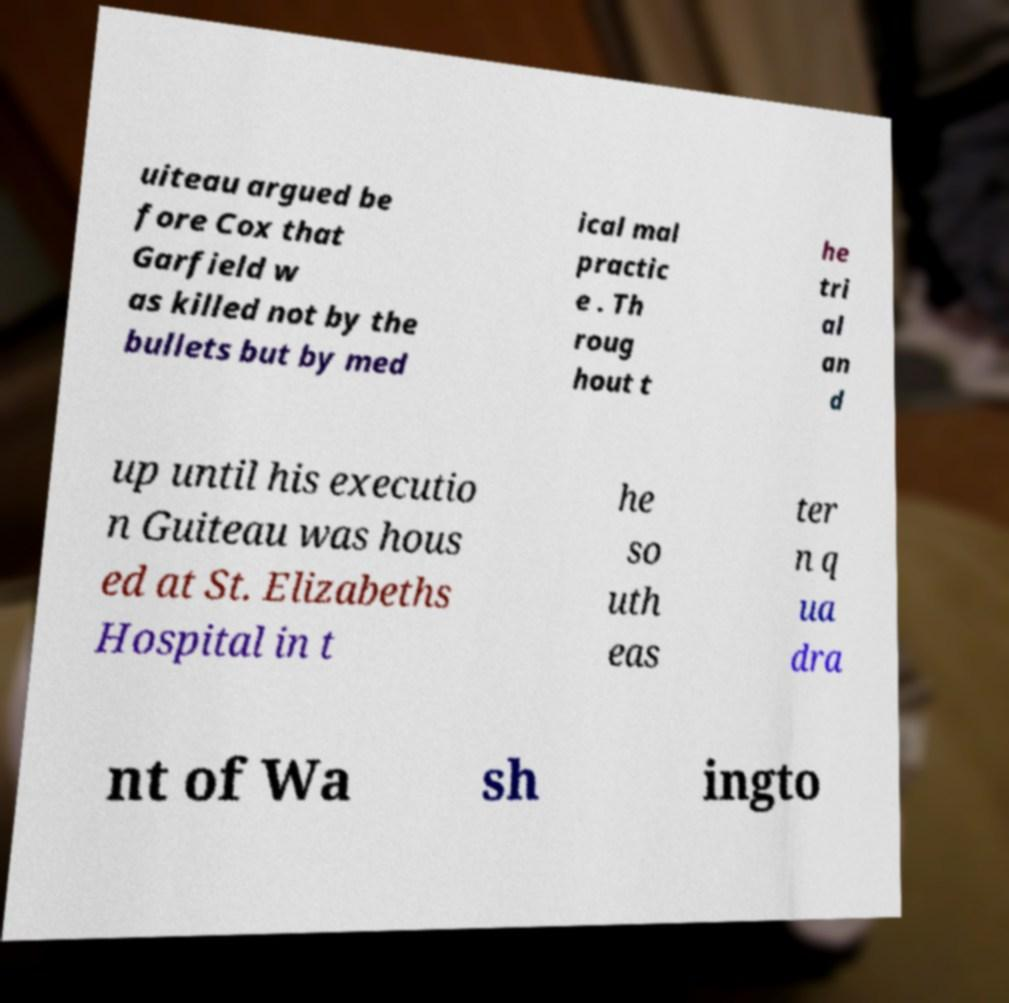Please identify and transcribe the text found in this image. uiteau argued be fore Cox that Garfield w as killed not by the bullets but by med ical mal practic e . Th roug hout t he tri al an d up until his executio n Guiteau was hous ed at St. Elizabeths Hospital in t he so uth eas ter n q ua dra nt of Wa sh ingto 